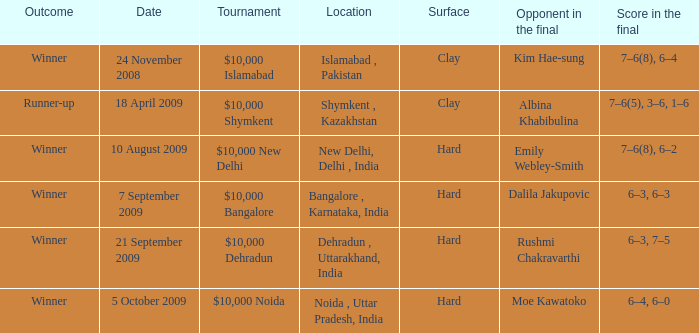What is the date of the game played in the bangalore , karnataka, india location 7 September 2009. 